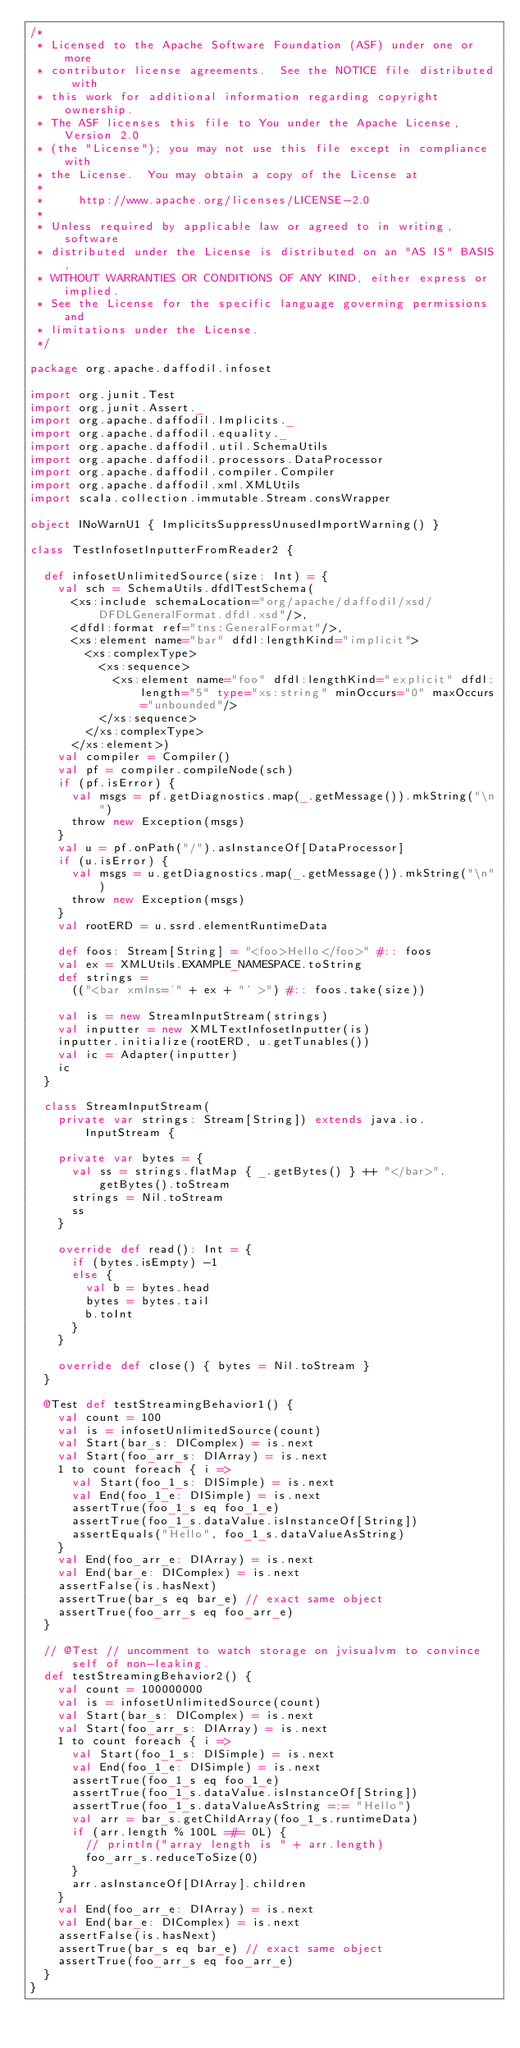Convert code to text. <code><loc_0><loc_0><loc_500><loc_500><_Scala_>/*
 * Licensed to the Apache Software Foundation (ASF) under one or more
 * contributor license agreements.  See the NOTICE file distributed with
 * this work for additional information regarding copyright ownership.
 * The ASF licenses this file to You under the Apache License, Version 2.0
 * (the "License"); you may not use this file except in compliance with
 * the License.  You may obtain a copy of the License at
 *
 *     http://www.apache.org/licenses/LICENSE-2.0
 *
 * Unless required by applicable law or agreed to in writing, software
 * distributed under the License is distributed on an "AS IS" BASIS,
 * WITHOUT WARRANTIES OR CONDITIONS OF ANY KIND, either express or implied.
 * See the License for the specific language governing permissions and
 * limitations under the License.
 */

package org.apache.daffodil.infoset

import org.junit.Test
import org.junit.Assert._
import org.apache.daffodil.Implicits._
import org.apache.daffodil.equality._
import org.apache.daffodil.util.SchemaUtils
import org.apache.daffodil.processors.DataProcessor
import org.apache.daffodil.compiler.Compiler
import org.apache.daffodil.xml.XMLUtils
import scala.collection.immutable.Stream.consWrapper

object INoWarnU1 { ImplicitsSuppressUnusedImportWarning() }

class TestInfosetInputterFromReader2 {

  def infosetUnlimitedSource(size: Int) = {
    val sch = SchemaUtils.dfdlTestSchema(
      <xs:include schemaLocation="org/apache/daffodil/xsd/DFDLGeneralFormat.dfdl.xsd"/>,
      <dfdl:format ref="tns:GeneralFormat"/>,
      <xs:element name="bar" dfdl:lengthKind="implicit">
        <xs:complexType>
          <xs:sequence>
            <xs:element name="foo" dfdl:lengthKind="explicit" dfdl:length="5" type="xs:string" minOccurs="0" maxOccurs="unbounded"/>
          </xs:sequence>
        </xs:complexType>
      </xs:element>)
    val compiler = Compiler()
    val pf = compiler.compileNode(sch)
    if (pf.isError) {
      val msgs = pf.getDiagnostics.map(_.getMessage()).mkString("\n")
      throw new Exception(msgs)
    }
    val u = pf.onPath("/").asInstanceOf[DataProcessor]
    if (u.isError) {
      val msgs = u.getDiagnostics.map(_.getMessage()).mkString("\n")
      throw new Exception(msgs)
    }
    val rootERD = u.ssrd.elementRuntimeData

    def foos: Stream[String] = "<foo>Hello</foo>" #:: foos
    val ex = XMLUtils.EXAMPLE_NAMESPACE.toString
    def strings =
      (("<bar xmlns='" + ex + "' >") #:: foos.take(size))

    val is = new StreamInputStream(strings)
    val inputter = new XMLTextInfosetInputter(is)
    inputter.initialize(rootERD, u.getTunables())
    val ic = Adapter(inputter)
    ic
  }

  class StreamInputStream(
    private var strings: Stream[String]) extends java.io.InputStream {

    private var bytes = {
      val ss = strings.flatMap { _.getBytes() } ++ "</bar>".getBytes().toStream
      strings = Nil.toStream
      ss
    }

    override def read(): Int = {
      if (bytes.isEmpty) -1
      else {
        val b = bytes.head
        bytes = bytes.tail
        b.toInt
      }
    }

    override def close() { bytes = Nil.toStream }
  }

  @Test def testStreamingBehavior1() {
    val count = 100
    val is = infosetUnlimitedSource(count)
    val Start(bar_s: DIComplex) = is.next
    val Start(foo_arr_s: DIArray) = is.next
    1 to count foreach { i =>
      val Start(foo_1_s: DISimple) = is.next
      val End(foo_1_e: DISimple) = is.next
      assertTrue(foo_1_s eq foo_1_e)
      assertTrue(foo_1_s.dataValue.isInstanceOf[String])
      assertEquals("Hello", foo_1_s.dataValueAsString)
    }
    val End(foo_arr_e: DIArray) = is.next
    val End(bar_e: DIComplex) = is.next
    assertFalse(is.hasNext)
    assertTrue(bar_s eq bar_e) // exact same object
    assertTrue(foo_arr_s eq foo_arr_e)
  }

  // @Test // uncomment to watch storage on jvisualvm to convince self of non-leaking.
  def testStreamingBehavior2() {
    val count = 100000000
    val is = infosetUnlimitedSource(count)
    val Start(bar_s: DIComplex) = is.next
    val Start(foo_arr_s: DIArray) = is.next
    1 to count foreach { i =>
      val Start(foo_1_s: DISimple) = is.next
      val End(foo_1_e: DISimple) = is.next
      assertTrue(foo_1_s eq foo_1_e)
      assertTrue(foo_1_s.dataValue.isInstanceOf[String])
      assertTrue(foo_1_s.dataValueAsString =:= "Hello")
      val arr = bar_s.getChildArray(foo_1_s.runtimeData)
      if (arr.length % 100L =#= 0L) {
        // println("array length is " + arr.length)
        foo_arr_s.reduceToSize(0)
      }
      arr.asInstanceOf[DIArray].children
    }
    val End(foo_arr_e: DIArray) = is.next
    val End(bar_e: DIComplex) = is.next
    assertFalse(is.hasNext)
    assertTrue(bar_s eq bar_e) // exact same object
    assertTrue(foo_arr_s eq foo_arr_e)
  }
}
</code> 